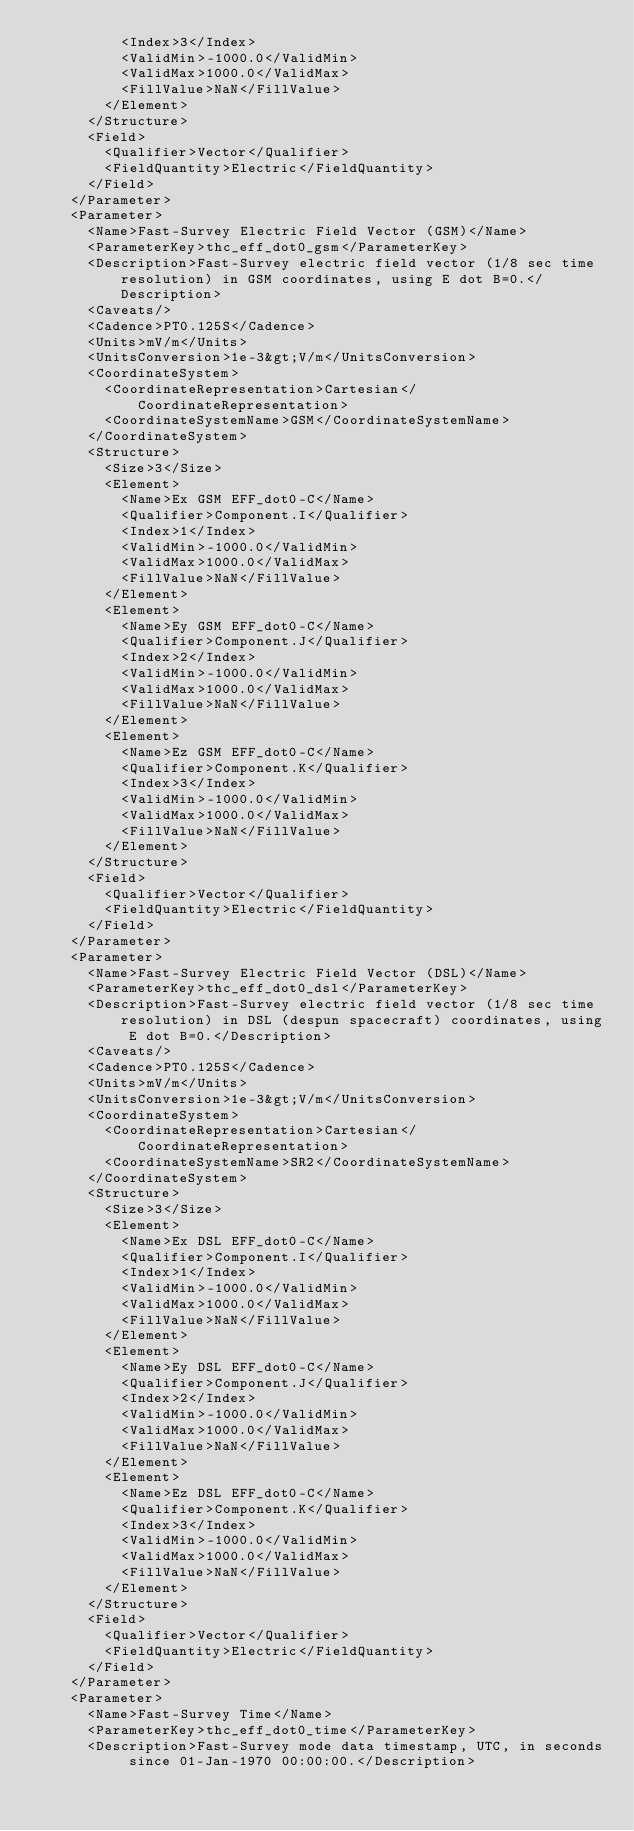Convert code to text. <code><loc_0><loc_0><loc_500><loc_500><_XML_>          <Index>3</Index>
          <ValidMin>-1000.0</ValidMin>
          <ValidMax>1000.0</ValidMax>
          <FillValue>NaN</FillValue>
        </Element>
      </Structure>
      <Field>
        <Qualifier>Vector</Qualifier>
        <FieldQuantity>Electric</FieldQuantity>
      </Field>
    </Parameter>
    <Parameter>
      <Name>Fast-Survey Electric Field Vector (GSM)</Name>
      <ParameterKey>thc_eff_dot0_gsm</ParameterKey>
      <Description>Fast-Survey electric field vector (1/8 sec time resolution) in GSM coordinates, using E dot B=0.</Description>
      <Caveats/>
      <Cadence>PT0.125S</Cadence>
      <Units>mV/m</Units>
      <UnitsConversion>1e-3&gt;V/m</UnitsConversion>
      <CoordinateSystem>
        <CoordinateRepresentation>Cartesian</CoordinateRepresentation>
        <CoordinateSystemName>GSM</CoordinateSystemName>
      </CoordinateSystem>
      <Structure>
        <Size>3</Size>
        <Element>
          <Name>Ex GSM EFF_dot0-C</Name>
          <Qualifier>Component.I</Qualifier>
          <Index>1</Index>
          <ValidMin>-1000.0</ValidMin>
          <ValidMax>1000.0</ValidMax>
          <FillValue>NaN</FillValue>
        </Element>
        <Element>
          <Name>Ey GSM EFF_dot0-C</Name>
          <Qualifier>Component.J</Qualifier>
          <Index>2</Index>
          <ValidMin>-1000.0</ValidMin>
          <ValidMax>1000.0</ValidMax>
          <FillValue>NaN</FillValue>
        </Element>
        <Element>
          <Name>Ez GSM EFF_dot0-C</Name>
          <Qualifier>Component.K</Qualifier>
          <Index>3</Index>
          <ValidMin>-1000.0</ValidMin>
          <ValidMax>1000.0</ValidMax>
          <FillValue>NaN</FillValue>
        </Element>
      </Structure>
      <Field>
        <Qualifier>Vector</Qualifier>
        <FieldQuantity>Electric</FieldQuantity>
      </Field>
    </Parameter>
    <Parameter>
      <Name>Fast-Survey Electric Field Vector (DSL)</Name>
      <ParameterKey>thc_eff_dot0_dsl</ParameterKey>
      <Description>Fast-Survey electric field vector (1/8 sec time resolution) in DSL (despun spacecraft) coordinates, using E dot B=0.</Description>
      <Caveats/>
      <Cadence>PT0.125S</Cadence>
      <Units>mV/m</Units>
      <UnitsConversion>1e-3&gt;V/m</UnitsConversion>
      <CoordinateSystem>
        <CoordinateRepresentation>Cartesian</CoordinateRepresentation>
        <CoordinateSystemName>SR2</CoordinateSystemName>
      </CoordinateSystem>
      <Structure>
        <Size>3</Size>
        <Element>
          <Name>Ex DSL EFF_dot0-C</Name>
          <Qualifier>Component.I</Qualifier>
          <Index>1</Index>
          <ValidMin>-1000.0</ValidMin>
          <ValidMax>1000.0</ValidMax>
          <FillValue>NaN</FillValue>
        </Element>
        <Element>
          <Name>Ey DSL EFF_dot0-C</Name>
          <Qualifier>Component.J</Qualifier>
          <Index>2</Index>
          <ValidMin>-1000.0</ValidMin>
          <ValidMax>1000.0</ValidMax>
          <FillValue>NaN</FillValue>
        </Element>
        <Element>
          <Name>Ez DSL EFF_dot0-C</Name>
          <Qualifier>Component.K</Qualifier>
          <Index>3</Index>
          <ValidMin>-1000.0</ValidMin>
          <ValidMax>1000.0</ValidMax>
          <FillValue>NaN</FillValue>
        </Element>
      </Structure>
      <Field>
        <Qualifier>Vector</Qualifier>
        <FieldQuantity>Electric</FieldQuantity>
      </Field>
    </Parameter>
    <Parameter>
      <Name>Fast-Survey Time</Name>
      <ParameterKey>thc_eff_dot0_time</ParameterKey>
      <Description>Fast-Survey mode data timestamp, UTC, in seconds since 01-Jan-1970 00:00:00.</Description></code> 